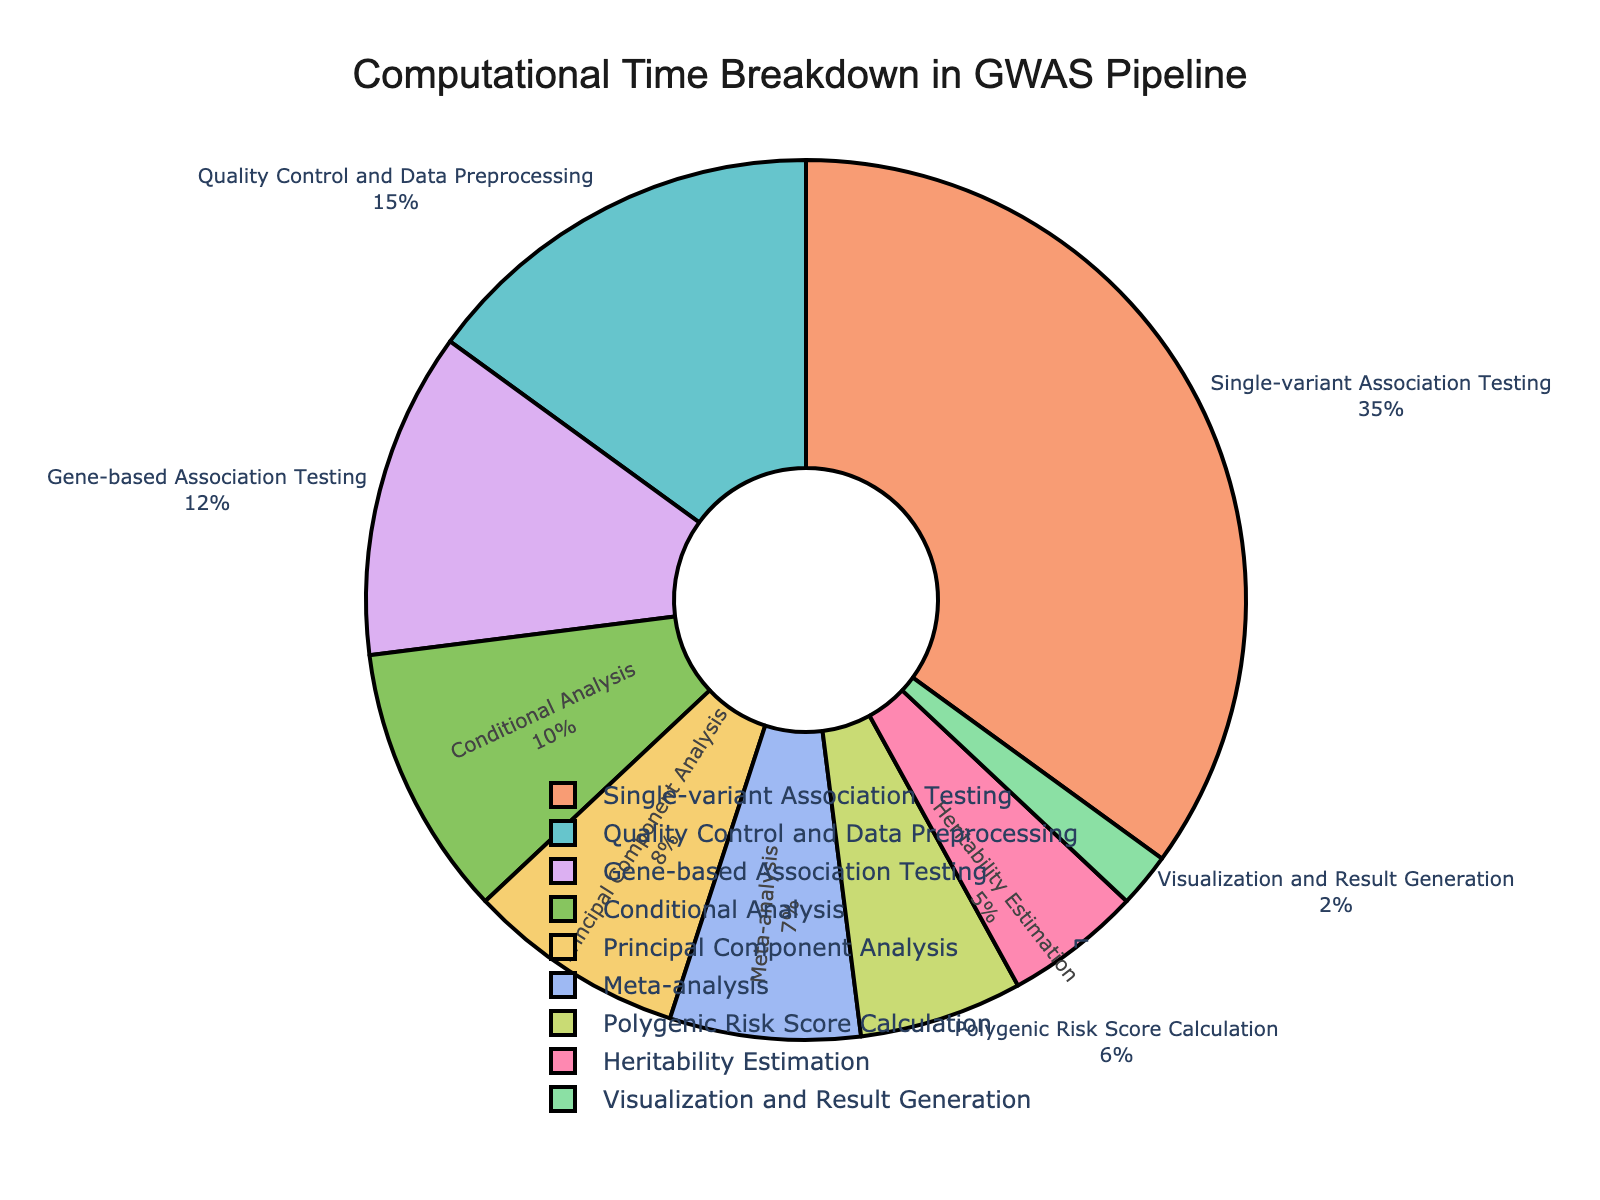What's the stage with the highest percentage of computational time? The figure shows a breakdown with percentages for each stage. By observing the pie chart, single-variant association testing has the largest slice, indicating the highest percentage.
Answer: Single-variant association testing What is the combined percentage of time spent on meta-analysis and heritability estimation? To find the combined percentage, add the percentage of meta-analysis (7%) to that of heritability estimation (5%). Therefore, 7 + 5 = 12.
Answer: 12% How much more time, in terms of percentage, is spent on quality control and preprocessing compared to the polygenic risk score calculation? The pie chart shows that quality control and preprocessing take up 15% of the time and polygenic risk score calculation takes up 6%. The difference is 15 - 6 = 9%.
Answer: 9% Which stage spends equal or less than 5% of computational time? By looking at the pie chart and the provided data, only heritability estimation takes exactly 5% of the computational time.
Answer: Heritability estimation What is the percentage difference between single-variant association testing and gene-based association testing? The single-variant association testing is 35%, while gene-based association testing is 12%. Subtracting these gives 35 - 12 = 23%.
Answer: 23% How does the time spent on conditional analysis compare to metaanalysis? Conditional analysis takes 10% of the computational time, and meta-analysis takes 7%. Therefore, conditional analysis takes 3% more time than meta-analysis.
Answer: 3% more Visual inspection shows which section has the smallest percentage of computational time? Observing the slices of the pie chart, the smallest slice, representing the smallest percentage, is for visualization and result generation at 2%.
Answer: Visualization and result generation What is the combined percentage of time spent on principal component analysis, meta-analysis, and polygenic risk score calculation? Sum the percentages for principal component analysis (8%), meta-analysis (7%), and polygenic risk score calculation (6%) for the combined total: 8 + 7 + 6 = 21.
Answer: 21% 